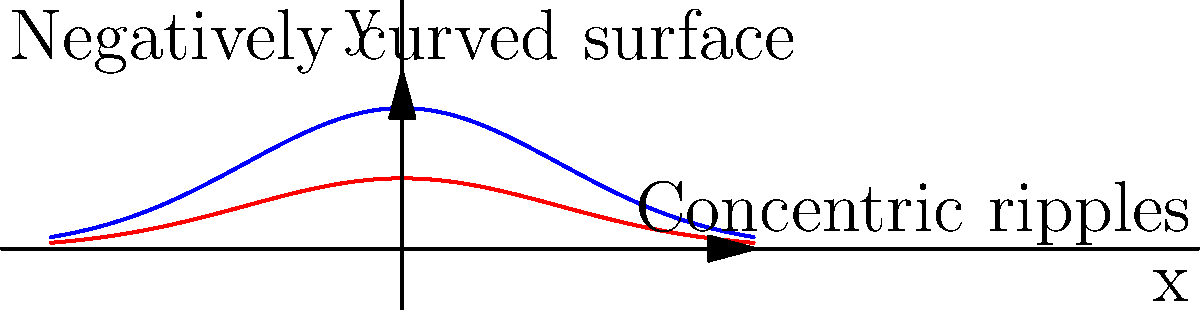In an art installation representing water ripples on a negatively curved surface, you notice that the area enclosed by each concentric ripple doesn't follow the familiar $A = \pi r^2$ formula. If the area $A(r)$ enclosed by a ripple at distance $r$ from the center is given by $A(r) = 2\pi (\cosh(r) - 1)$, what is the rate of change of the area with respect to $r$ when $r = 1$? To find the rate of change of the area with respect to $r$, we need to follow these steps:

1) The given area function is $A(r) = 2\pi (\cosh(r) - 1)$

2) To find the rate of change, we need to differentiate $A(r)$ with respect to $r$:

   $\frac{dA}{dr} = 2\pi \frac{d}{dr}(\cosh(r) - 1)$

3) Using the chain rule and the fact that $\frac{d}{dr}\cosh(r) = \sinh(r)$, we get:

   $\frac{dA}{dr} = 2\pi \sinh(r)$

4) We're asked to evaluate this at $r = 1$, so:

   $\left.\frac{dA}{dr}\right|_{r=1} = 2\pi \sinh(1)$

5) $\sinh(1) \approx 1.1752$, so:

   $\left.\frac{dA}{dr}\right|_{r=1} \approx 2\pi(1.1752) \approx 7.3816$

Therefore, when $r = 1$, the rate of change of the area with respect to $r$ is approximately $7.3816$ square units per unit distance.
Answer: $2\pi \sinh(1)$ square units per unit distance 